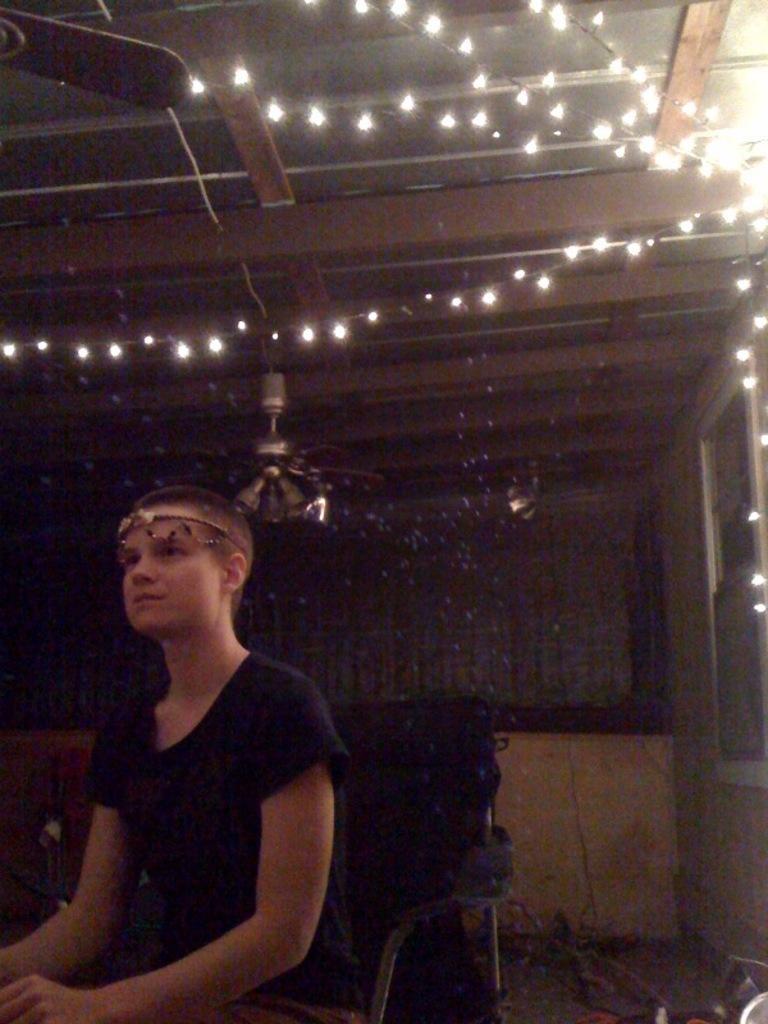Describe this image in one or two sentences. In this image, we can see a person is sitting on the chair. Background there is a wall. Here we can see a decorative lights. Top of the image, there is a ceiling with fans. 